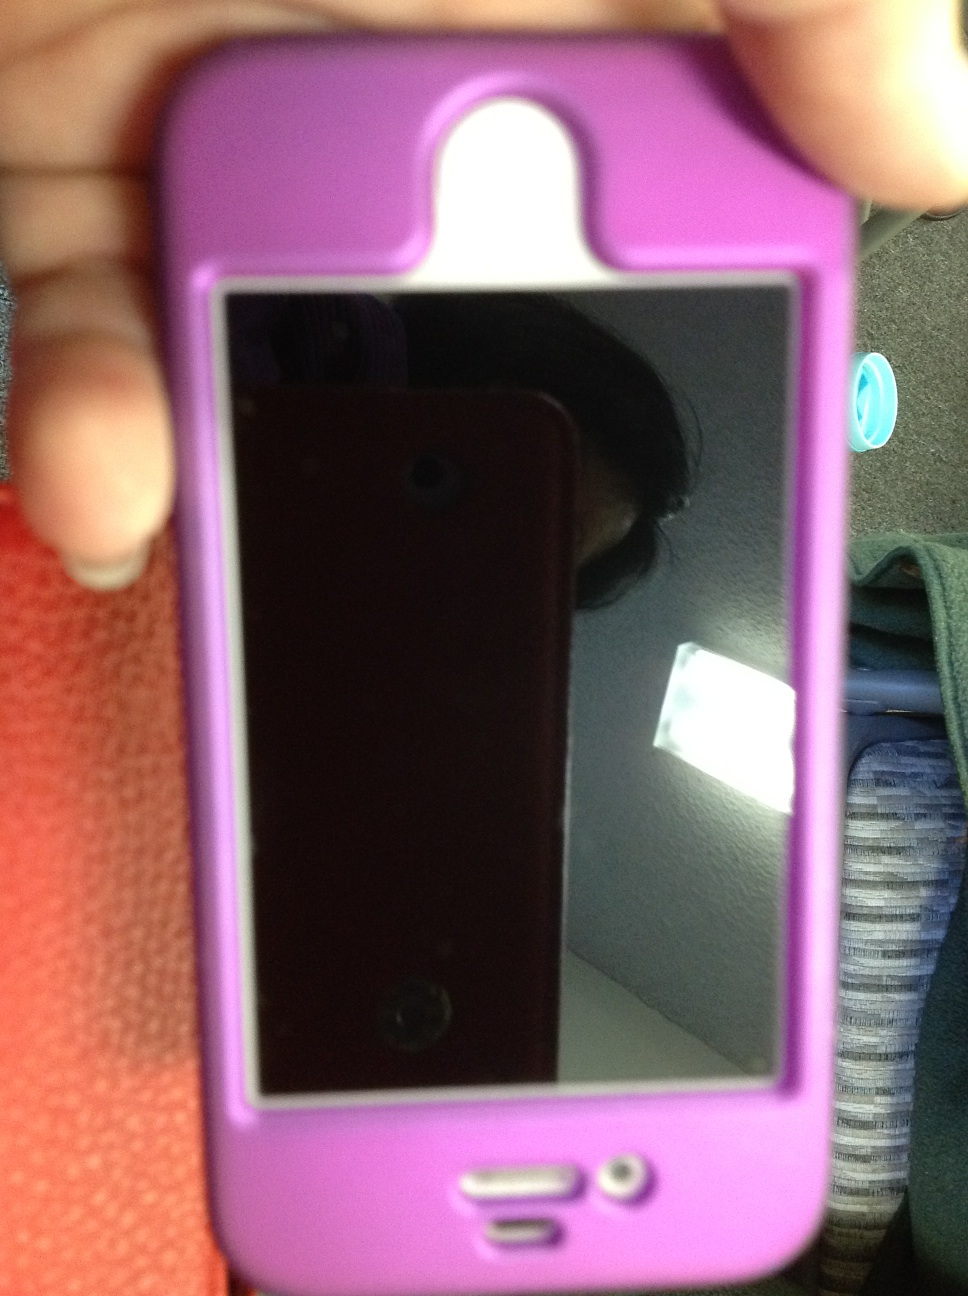What do you notice about the environment this phone is in? From the image, it appears that the phone is in a casual indoor environment. There is a hint of blue fabric which might suggest a piece of furniture, possibly a chair or sofa. The lighting indicates that this setting could be in a living area or an office space. A part of a ceiling light fixture is reflected on the phone's screen, suggesting it's taken in a room with overhead lighting. The background seems simple and tidy, without much clutter. What minor details can you observe about the phone and its surroundings? Looking closely, the phone case has a few minor scuff marks which imply it's been used regularly. The way the phone is being held suggests a casual, perhaps slightly hurried snapshot to capture the device quickly. The reflection on the screen reveals the presence of the person capturing the image, though only their outline can be seen. In the background, there is a glimpse of a textured surface, possibly a fabric, hinting at a cozy, lived-in environment. What could be happening in this scene? In this scene, it looks like someone might be sharing a quick picture of their iPhone with friends or on social media, to show off their pink case. They could be receiving or sending a message about the phone, capturing the condition of the device for a potential sale, or simply chronicling their belongings. The casual nature of the shot suggests it was taken spontaneously and quickly, possibly as part of a conversation or a moment of tech-related enthusiasm. 